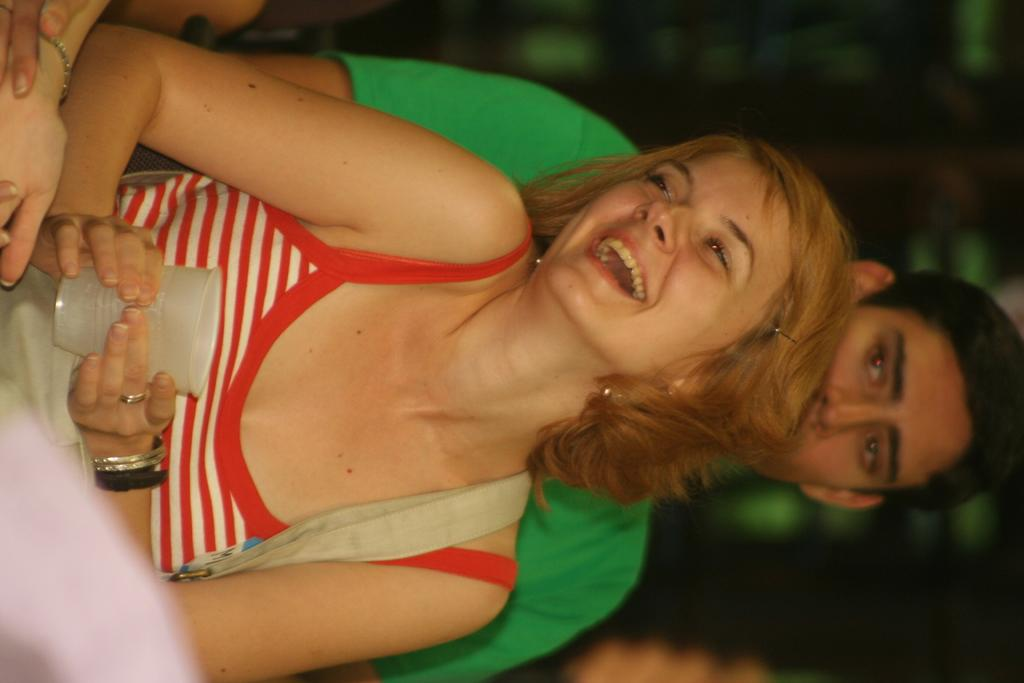How many people are in the image? There are two people in the image. Can you describe one of the people in the image? One of the people is a woman. What is the woman holding in the image? The woman is holding a white color cup. What colors are the dresses of the people in the image? The people are wearing red, green, and white color dresses. How would you describe the background of the image? The background of the image is blurred. What type of breakfast is being served in the image? There is no breakfast visible in the image. Can you tell me how many bells are present in the image? There are no bells present in the image. 